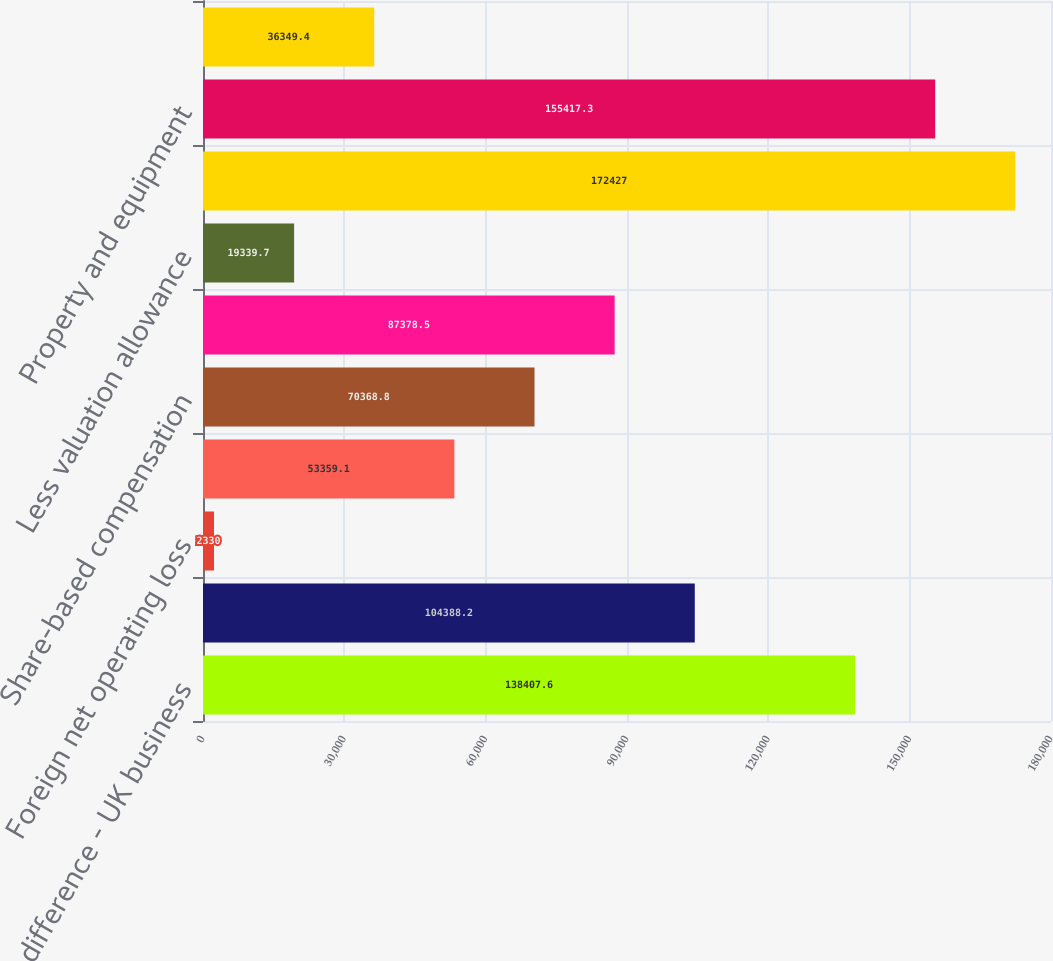<chart> <loc_0><loc_0><loc_500><loc_500><bar_chart><fcel>Basis difference - UK business<fcel>Foreign income tax credit<fcel>Foreign net operating loss<fcel>US net operating loss<fcel>Share-based compensation<fcel>Other<fcel>Less valuation allowance<fcel>Acquired intangible assets<fcel>Property and equipment<fcel>Taxes on unremitted earnings<nl><fcel>138408<fcel>104388<fcel>2330<fcel>53359.1<fcel>70368.8<fcel>87378.5<fcel>19339.7<fcel>172427<fcel>155417<fcel>36349.4<nl></chart> 